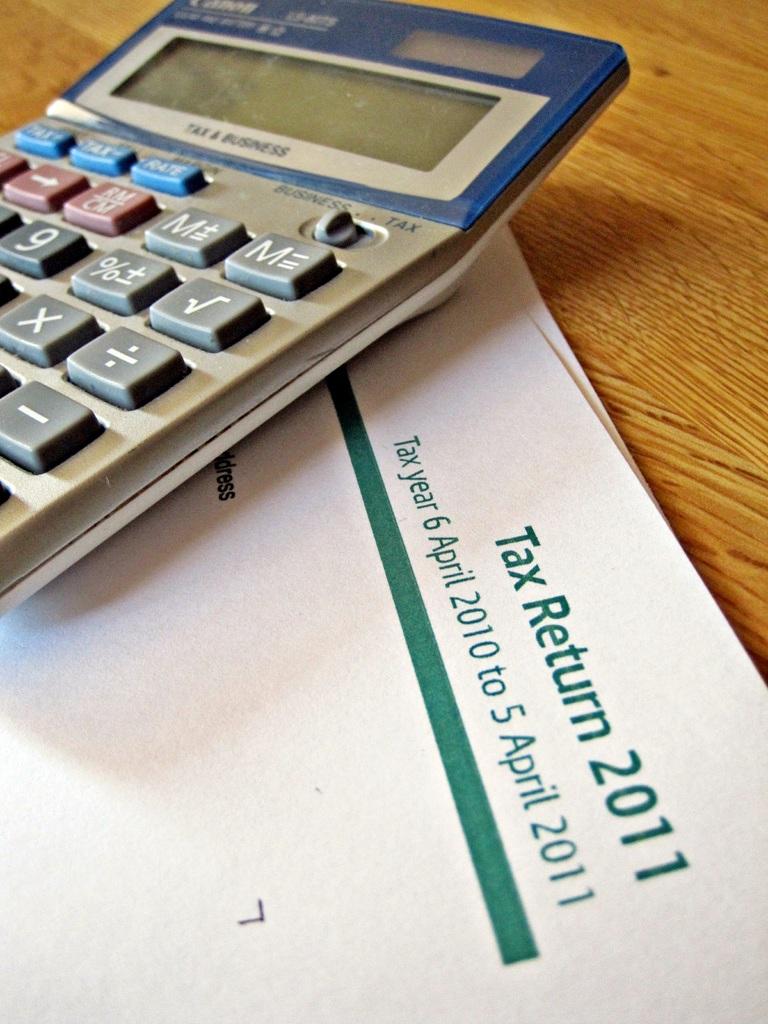What year are these tax forms?
Your answer should be compact. 2011. What is the first date?
Your answer should be compact. 6 april 2010. 